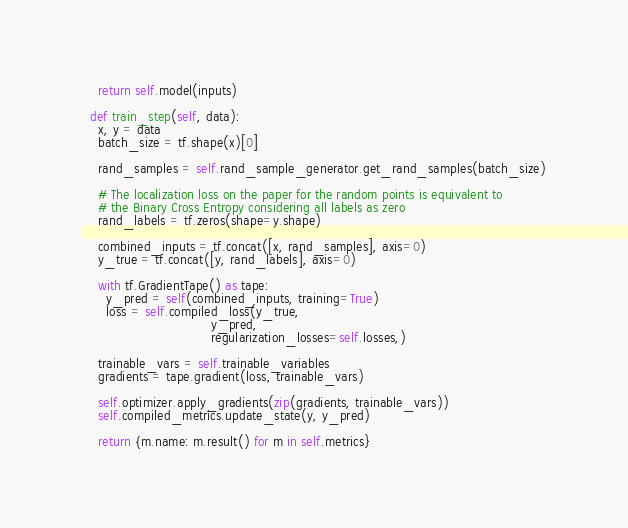<code> <loc_0><loc_0><loc_500><loc_500><_Python_>    return self.model(inputs)

  def train_step(self, data):
    x, y = data
    batch_size = tf.shape(x)[0]

    rand_samples = self.rand_sample_generator.get_rand_samples(batch_size)

    # The localization loss on the paper for the random points is equivalent to
    # the Binary Cross Entropy considering all labels as zero
    rand_labels = tf.zeros(shape=y.shape)

    combined_inputs = tf.concat([x, rand_samples], axis=0)
    y_true = tf.concat([y, rand_labels], axis=0)

    with tf.GradientTape() as tape:
      y_pred = self(combined_inputs, training=True)
      loss = self.compiled_loss(y_true,
                                y_pred,
                                regularization_losses=self.losses,)

    trainable_vars = self.trainable_variables
    gradients = tape.gradient(loss, trainable_vars)

    self.optimizer.apply_gradients(zip(gradients, trainable_vars))
    self.compiled_metrics.update_state(y, y_pred)

    return {m.name: m.result() for m in self.metrics}
</code> 